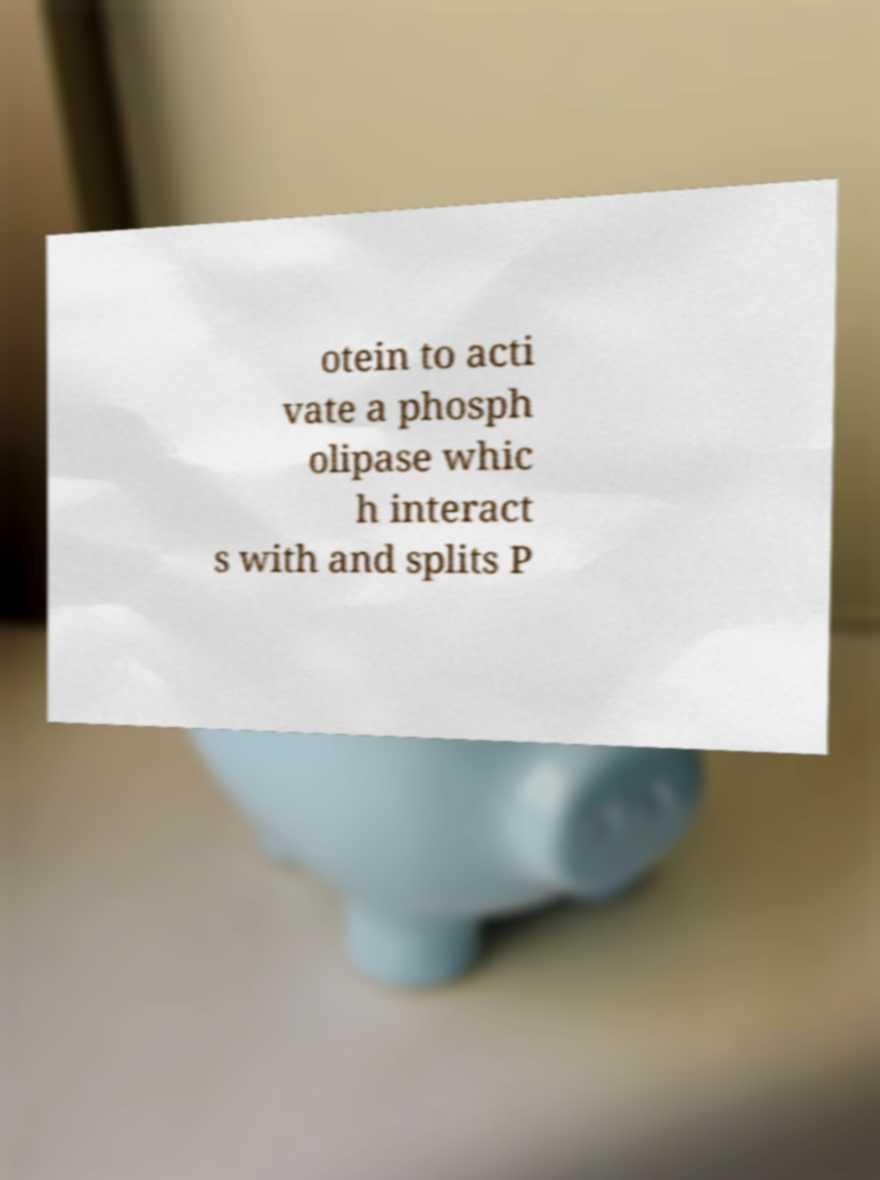Could you assist in decoding the text presented in this image and type it out clearly? otein to acti vate a phosph olipase whic h interact s with and splits P 